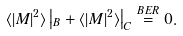<formula> <loc_0><loc_0><loc_500><loc_500>\langle | M | ^ { 2 } \rangle \left | _ { B } + \langle | M | ^ { 2 } \rangle \right | _ { C } \stackrel { B E R } { = } 0 .</formula> 